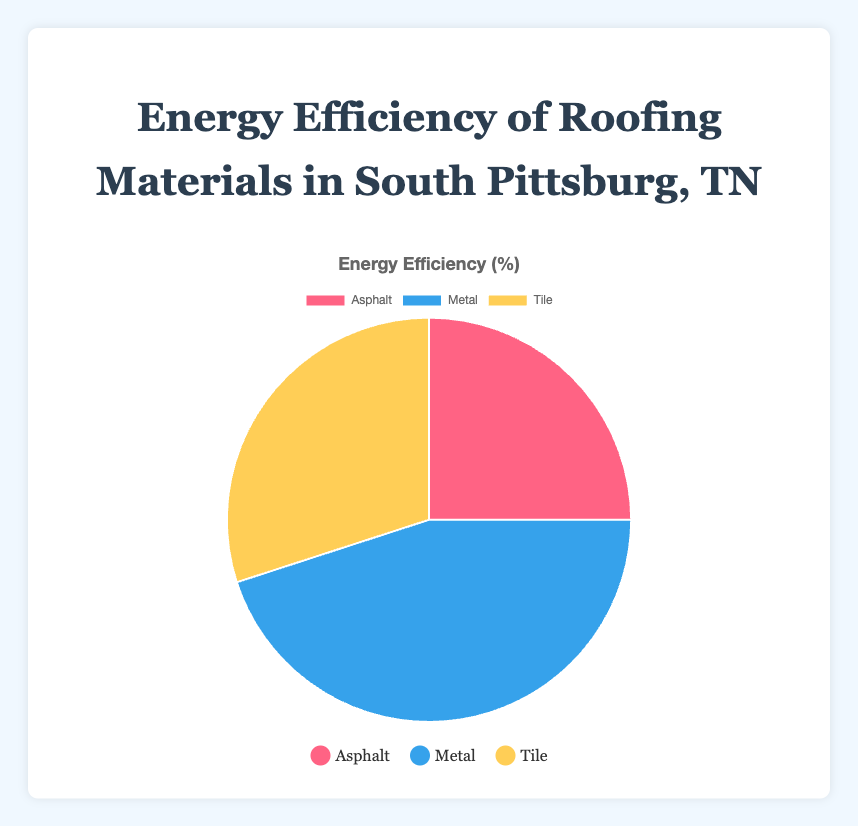Which roofing material has the highest energy efficiency? The metal roofing material has the highest energy efficiency at 45%, as indicated by the largest slice of the pie chart.
Answer: Metal Which roofing material has the lowest energy efficiency? The asphalt roofing material has the lowest energy efficiency at 25%, as indicated by the smallest slice of the pie chart.
Answer: Asphalt What is the difference in energy efficiency between metal and asphalt roofing materials? The energy efficiency of metal is 45%, and asphalt is 25%. The difference can be calculated as 45% - 25% = 20%.
Answer: 20% What is the total energy efficiency percentage for tile and metal combined? The energy efficiency of tile is 30%, and metal is 45%. Adding these together gives 30% + 45% = 75%.
Answer: 75% What is the average energy efficiency of the roofing materials? The individual energy efficiencies are 25% (asphalt), 45% (metal), and 30% (tile). Adding these together gives 25% + 45% + 30% = 100%. The average is 100% / 3 = 33.33%.
Answer: 33.33% Which roofing material is represented by the yellow slice in the pie chart? The yellow slice in the pie chart corresponds to tile, based on the legend provided.
Answer: Tile Compare the energy efficiency of tile to that of asphalt. The tile has an energy efficiency of 30%, while asphalt has 25%. Tile is 5% more energy efficient than asphalt (30% - 25%).
Answer: Tile is 5% more efficient If choosing a roofing material based on energy efficiency, which would be the least recommended? Based on energy efficiency, the least recommended roofing material would be asphalt, as it has the lowest efficiency at 25%.
Answer: Asphalt What is the combined energy efficiency of the two least efficient materials? The two least efficient materials are asphalt (25%) and tile (30%). Adding these together gives 25% + 30% = 55%.
Answer: 55% What percentage of the pie chart is covered by the most efficient roofing material? The most efficient roofing material is metal, accounting for 45% of the pie chart.
Answer: 45% 